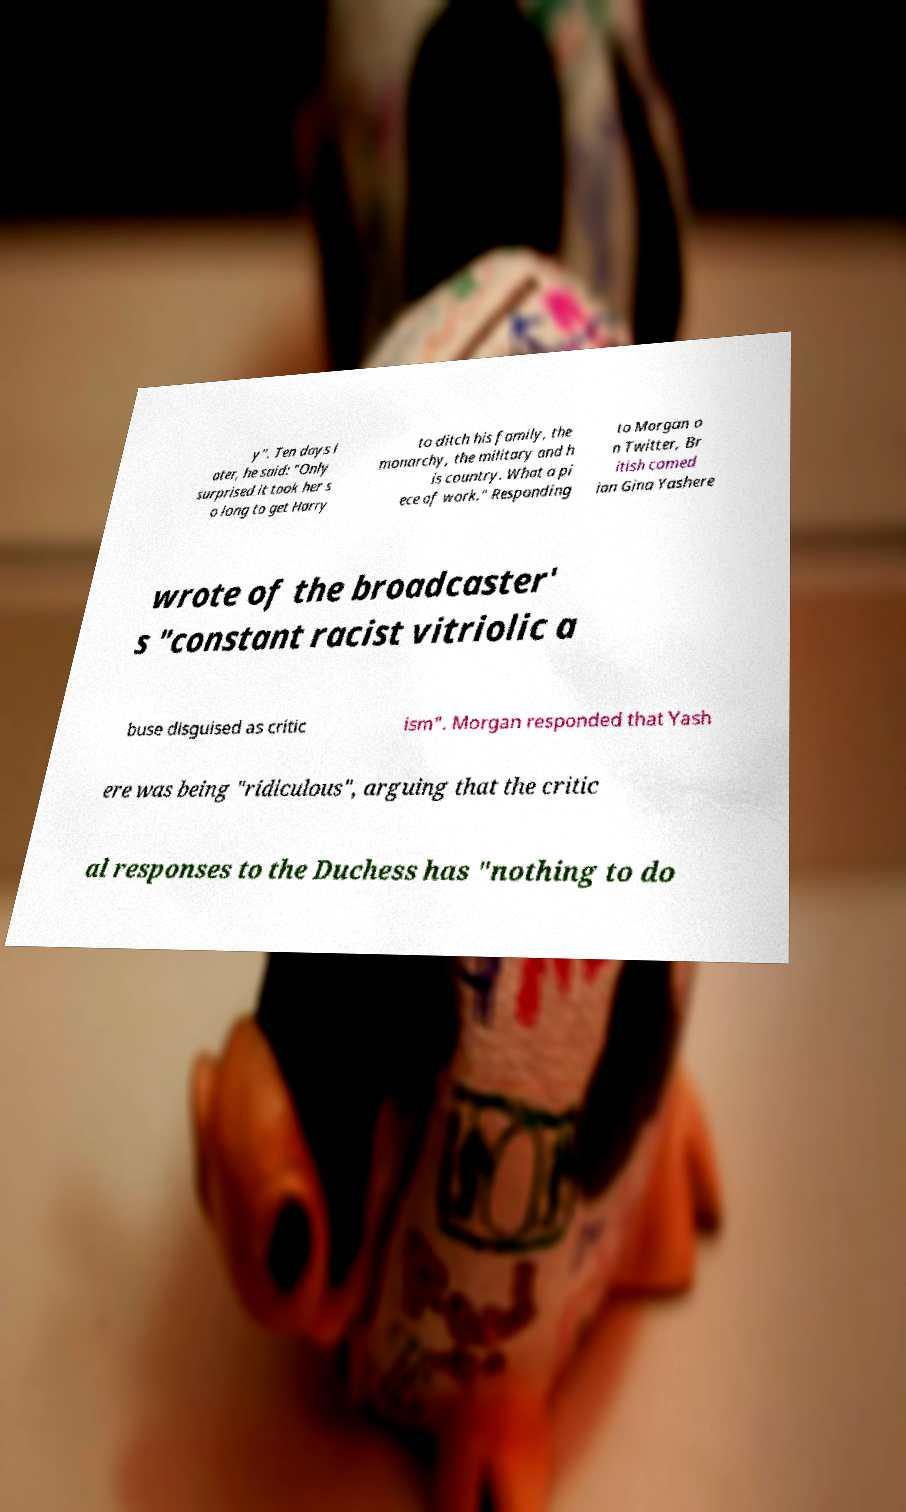I need the written content from this picture converted into text. Can you do that? y". Ten days l ater, he said: "Only surprised it took her s o long to get Harry to ditch his family, the monarchy, the military and h is country. What a pi ece of work." Responding to Morgan o n Twitter, Br itish comed ian Gina Yashere wrote of the broadcaster' s "constant racist vitriolic a buse disguised as critic ism". Morgan responded that Yash ere was being "ridiculous", arguing that the critic al responses to the Duchess has "nothing to do 